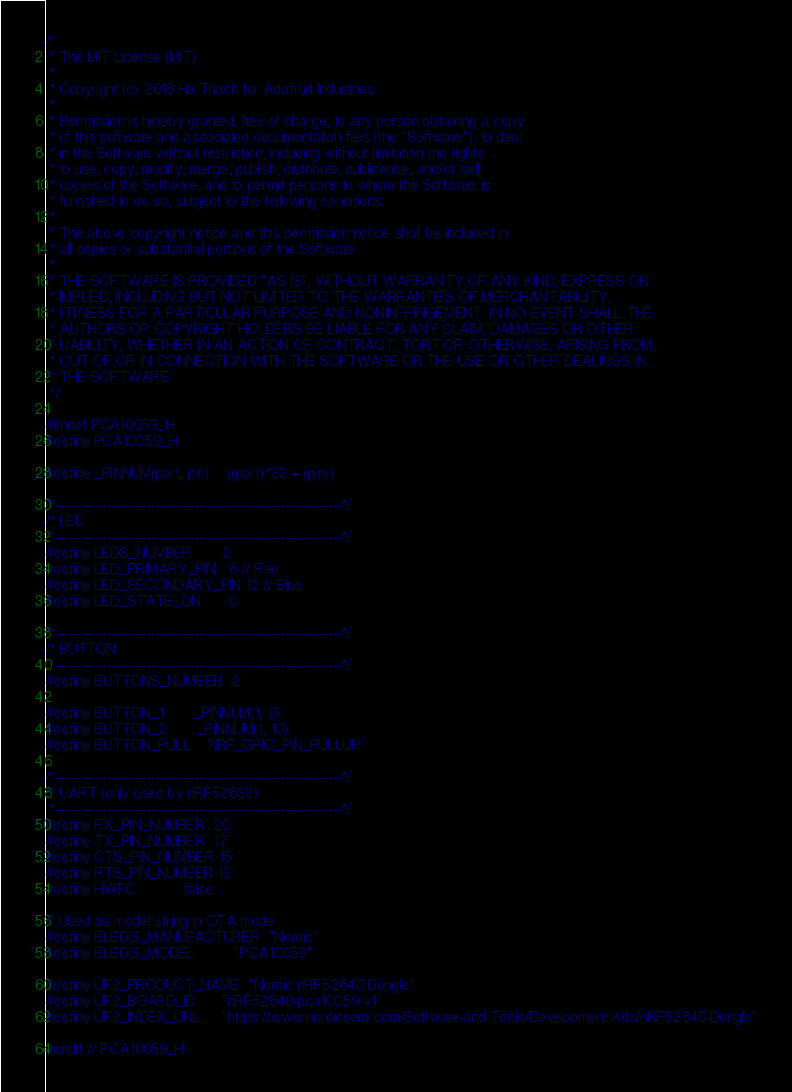<code> <loc_0><loc_0><loc_500><loc_500><_C_>/*
 * The MIT License (MIT)
 *
 * Copyright (c) 2018 Ha Thach for Adafruit Industries
 *
 * Permission is hereby granted, free of charge, to any person obtaining a copy
 * of this software and associated documentation files (the "Software"), to deal
 * in the Software without restriction, including without limitation the rights
 * to use, copy, modify, merge, publish, distribute, sublicense, and/or sell
 * copies of the Software, and to permit persons to whom the Software is
 * furnished to do so, subject to the following conditions:
 *
 * The above copyright notice and this permission notice shall be included in
 * all copies or substantial portions of the Software.
 *
 * THE SOFTWARE IS PROVIDED "AS IS", WITHOUT WARRANTY OF ANY KIND, EXPRESS OR
 * IMPLIED, INCLUDING BUT NOT LIMITED TO THE WARRANTIES OF MERCHANTABILITY,
 * FITNESS FOR A PARTICULAR PURPOSE AND NONINFRINGEMENT. IN NO EVENT SHALL THE
 * AUTHORS OR COPYRIGHT HOLDERS BE LIABLE FOR ANY CLAIM, DAMAGES OR OTHER
 * LIABILITY, WHETHER IN AN ACTION OF CONTRACT, TORT OR OTHERWISE, ARISING FROM,
 * OUT OF OR IN CONNECTION WITH THE SOFTWARE OR THE USE OR OTHER DEALINGS IN
 * THE SOFTWARE.
 */

#ifndef PCA10059_H
#define PCA10059_H

#define _PINNUM(port, pin)    ((port)*32 + (pin))

/*------------------------------------------------------------------*/
/* LED
 *------------------------------------------------------------------*/
#define LEDS_NUMBER       2
#define LED_PRIMARY_PIN   6 // Red
#define LED_SECONDARY_PIN 12 // Blue
#define LED_STATE_ON      0

/*------------------------------------------------------------------*/
/* BUTTON
 *------------------------------------------------------------------*/
#define BUTTONS_NUMBER  2

#define BUTTON_1       _PINNUM(1, 6)
#define BUTTON_2       _PINNUM(1, 10)
#define BUTTON_PULL    NRF_GPIO_PIN_PULLUP

/*------------------------------------------------------------------*/
/* UART (only used by nRF52832)
 *------------------------------------------------------------------*/
#define RX_PIN_NUMBER  20
#define TX_PIN_NUMBER  17
#define CTS_PIN_NUMBER 15
#define RTS_PIN_NUMBER 13
#define HWFC           false

// Used as model string in OTA mode
#define BLEDIS_MANUFACTURER  "Nordic"
#define BLEDIS_MODEL         "PCA10059"

#define UF2_PRODUCT_NAME  "Nordic nRF52840 Dongle"
#define UF2_BOARD_ID      "nRF52840-pca10059-v1"
#define UF2_INDEX_URL     "https://www.nordicsemi.com/Software-and-Tools/Development-Kits/nRF52840-Dongle"

#endif // PCA10059_H
</code> 